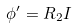<formula> <loc_0><loc_0><loc_500><loc_500>\phi ^ { \prime } = R _ { 2 } I</formula> 